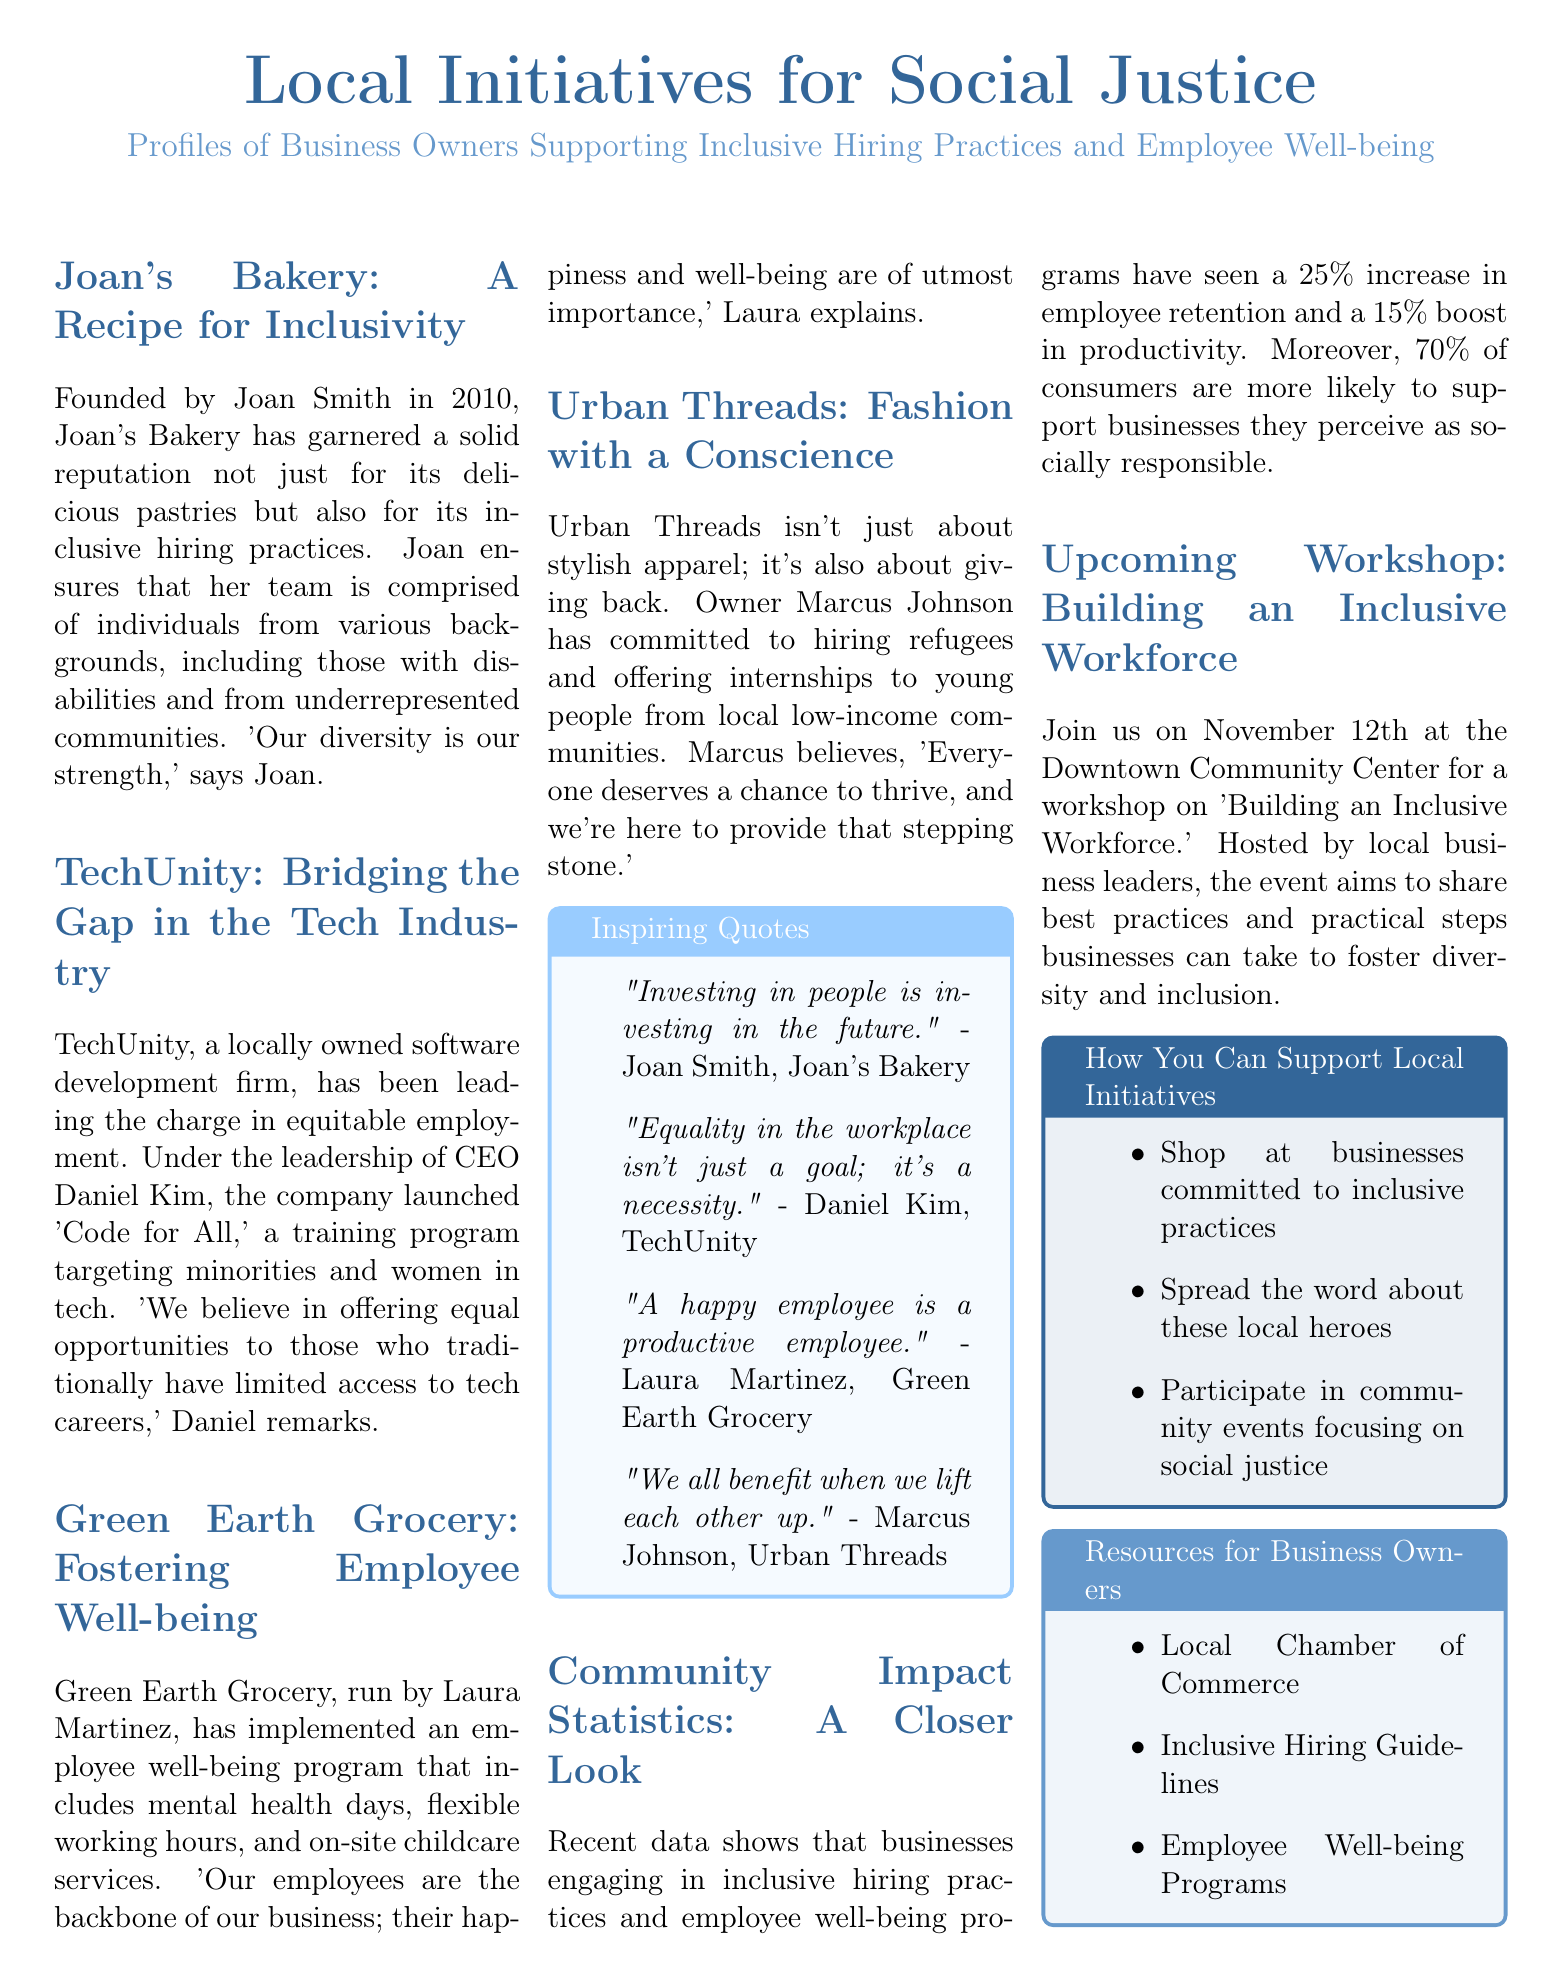What year was Joan's Bakery founded? Joan's Bakery was founded in 2010, as stated in the profile of the business.
Answer: 2010 What is the name of the program launched by TechUnity? The program launched by TechUnity is called 'Code for All.'
Answer: Code for All Who is the owner of Green Earth Grocery? The owner of Green Earth Grocery is Laura Martinez, mentioned in her section.
Answer: Laura Martinez What percentage increase in employee retention is noted for inclusive businesses? The document mentions a 25% increase in employee retention for businesses engaging in inclusive practices.
Answer: 25% What is the purpose of the upcoming workshop on November 12th? The purpose of the workshop is to share best practices and practical steps for fostering diversity and inclusion in the workforce.
Answer: To share best practices for fostering diversity and inclusion What funding source is suggested for business owners looking to improve inclusivity? The document lists the Local Chamber of Commerce as a resource for business owners.
Answer: Local Chamber of Commerce What percentage of consumers support socially responsible businesses? According to the document, 70% of consumers are more likely to support socially responsible businesses.
Answer: 70% What is the main focus of Urban Threads? Urban Threads focuses on hiring refugees and offering internships to local youth from low-income communities.
Answer: Hiring refugees and offering internships What is Joan Smith’s quote regarding investing in people? Joan Smith states, "Investing in people is investing in the future."
Answer: Investing in people is investing in the future 